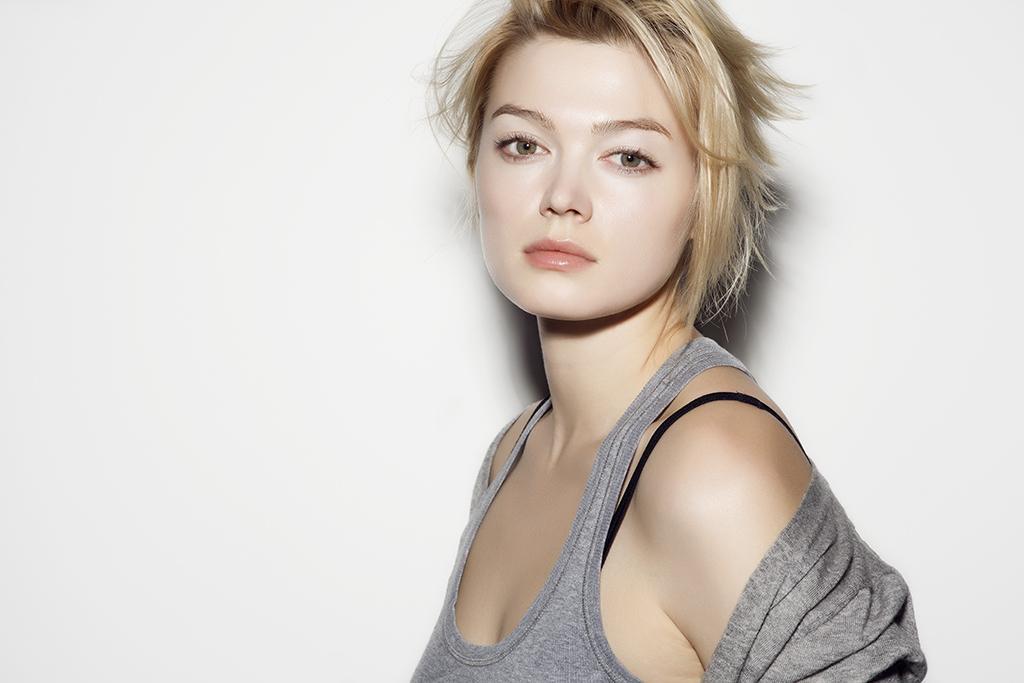How would you summarize this image in a sentence or two? In this image we can see a lady. In the background it is white. 